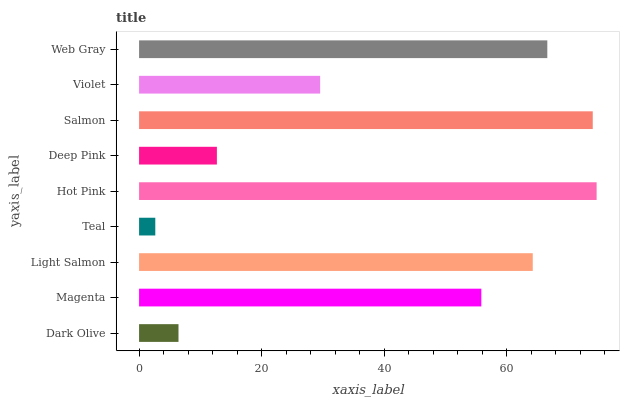Is Teal the minimum?
Answer yes or no. Yes. Is Hot Pink the maximum?
Answer yes or no. Yes. Is Magenta the minimum?
Answer yes or no. No. Is Magenta the maximum?
Answer yes or no. No. Is Magenta greater than Dark Olive?
Answer yes or no. Yes. Is Dark Olive less than Magenta?
Answer yes or no. Yes. Is Dark Olive greater than Magenta?
Answer yes or no. No. Is Magenta less than Dark Olive?
Answer yes or no. No. Is Magenta the high median?
Answer yes or no. Yes. Is Magenta the low median?
Answer yes or no. Yes. Is Teal the high median?
Answer yes or no. No. Is Light Salmon the low median?
Answer yes or no. No. 